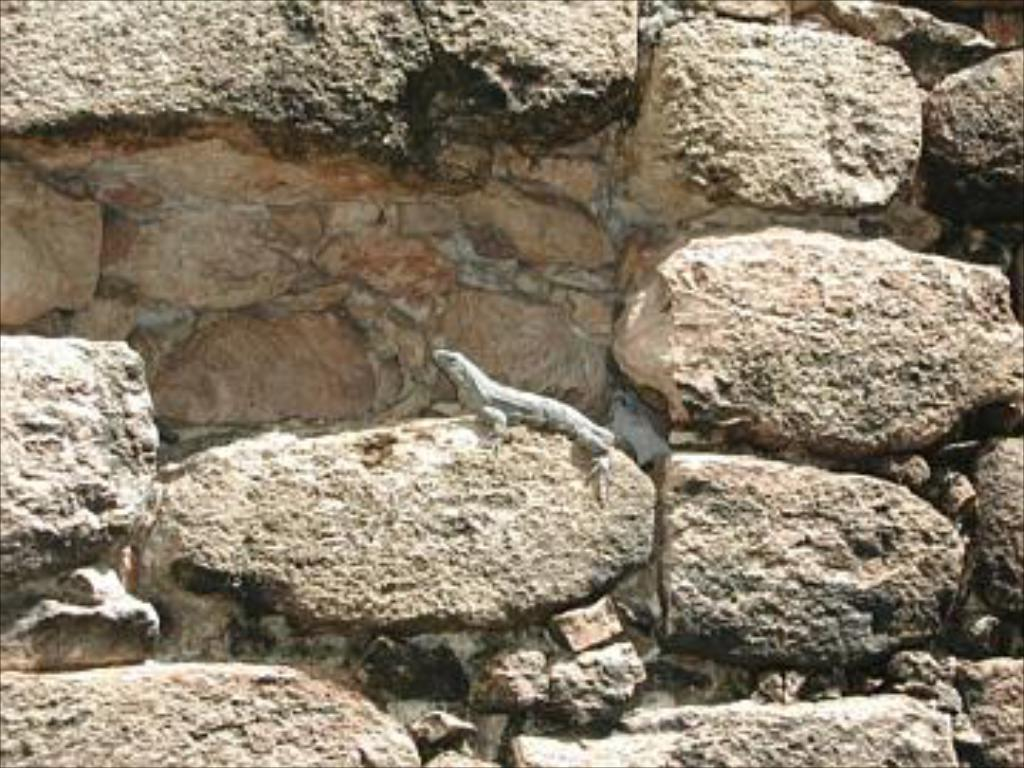What can be seen in the image? There is a wall in the image. What material is the wall made of? The wall is built with huge stones. Is there any living creature visible on the wall? Yes, there is a lizard on one of the stones. What type of park can be seen in the image? There is no park present in the image; it features a wall built with huge stones and a lizard on one of the stones. How many fangs does the lizard have in the image? It is impossible to determine the number of fangs the lizard has from the image alone, as the lizard's mouth is not visible. 